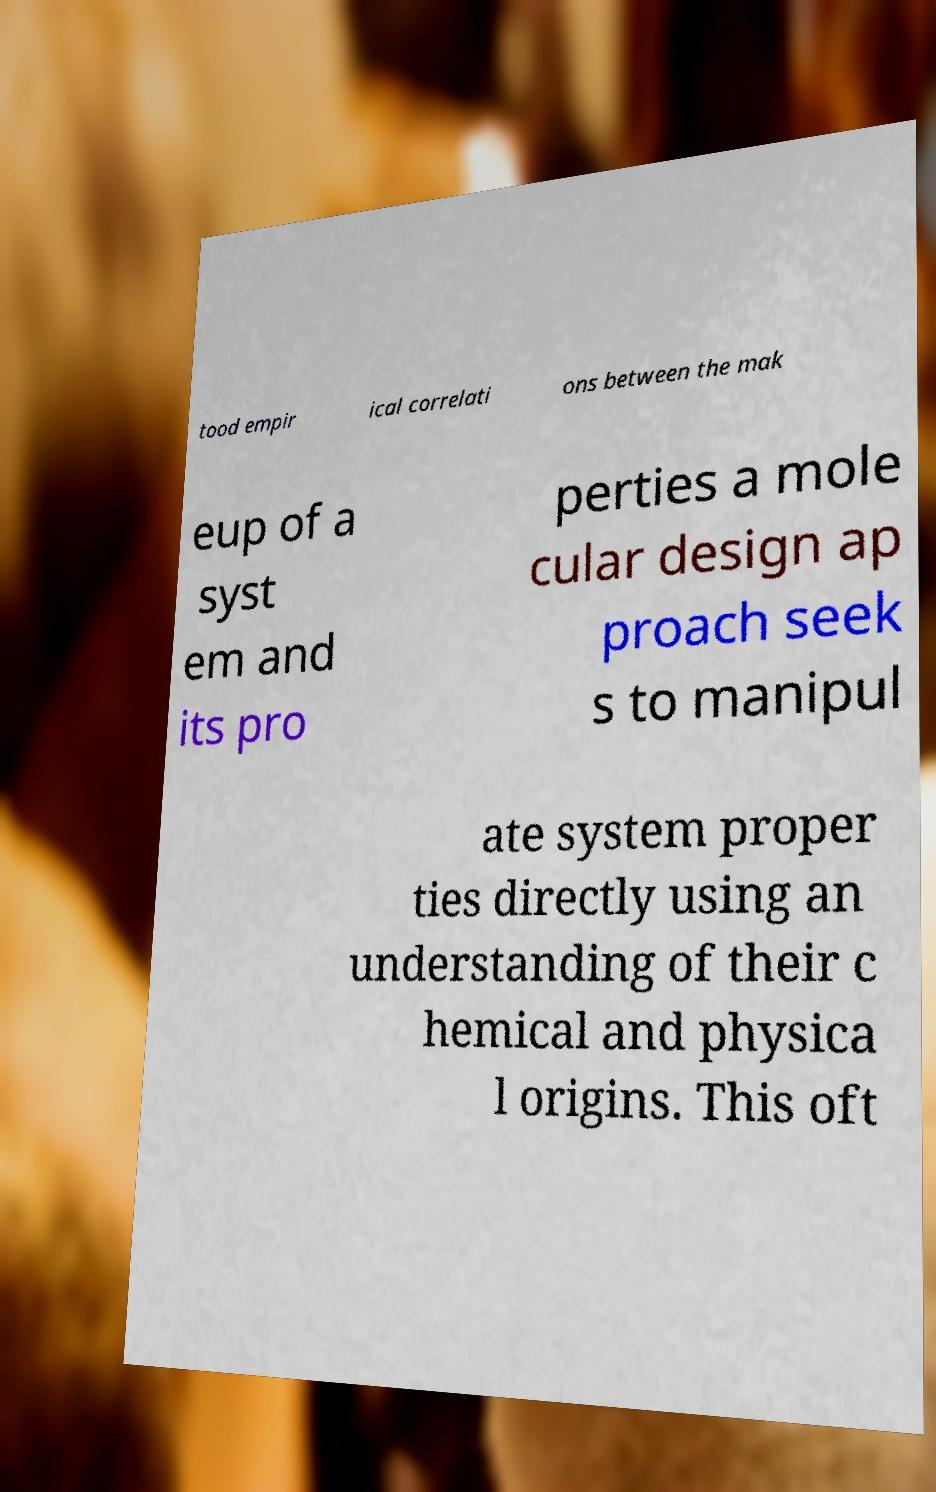Can you accurately transcribe the text from the provided image for me? tood empir ical correlati ons between the mak eup of a syst em and its pro perties a mole cular design ap proach seek s to manipul ate system proper ties directly using an understanding of their c hemical and physica l origins. This oft 